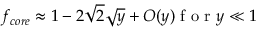<formula> <loc_0><loc_0><loc_500><loc_500>f _ { c o r e } \approx 1 - 2 \sqrt { 2 } \sqrt { y } + O ( y ) f o r y \ll 1</formula> 